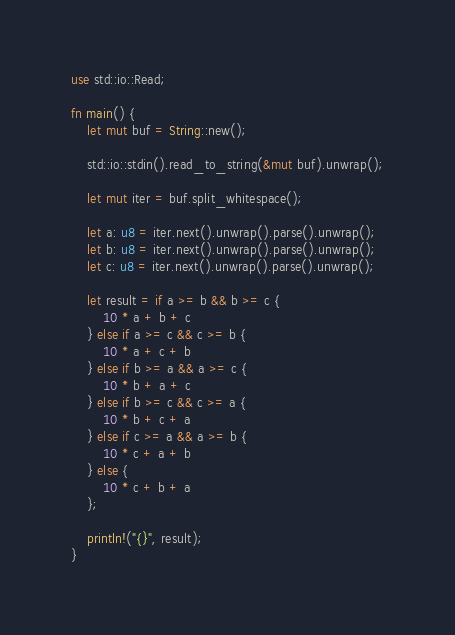<code> <loc_0><loc_0><loc_500><loc_500><_Rust_>use std::io::Read;

fn main() {
    let mut buf = String::new();

    std::io::stdin().read_to_string(&mut buf).unwrap();

    let mut iter = buf.split_whitespace();

    let a: u8 = iter.next().unwrap().parse().unwrap();
    let b: u8 = iter.next().unwrap().parse().unwrap();
    let c: u8 = iter.next().unwrap().parse().unwrap();

    let result = if a >= b && b >= c {
        10 * a + b + c
    } else if a >= c && c >= b {
        10 * a + c + b
    } else if b >= a && a >= c {
        10 * b + a + c
    } else if b >= c && c >= a {
        10 * b + c + a
    } else if c >= a && a >= b {
        10 * c + a + b
    } else {
        10 * c + b + a
    };

    println!("{}", result);
}
</code> 